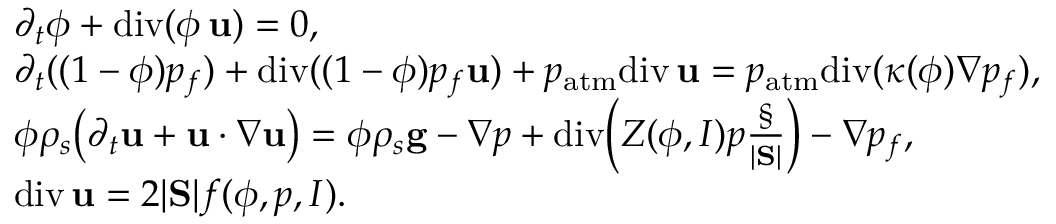<formula> <loc_0><loc_0><loc_500><loc_500>\begin{array} { r l } & { \partial _ { t } \phi + d i v ( \phi \, { u } ) = 0 , } \\ & { \partial _ { t } ( ( 1 - \phi ) p _ { f } ) + d i v ( ( 1 - \phi ) p _ { f } { u } ) + p _ { a t m } d i v \, { u } = p _ { a t m } d i v ( \kappa ( \phi ) \nabla p _ { f } ) , } \\ & { \phi \rho _ { s } \left ( \partial _ { t } { u } + { u } \cdot \nabla { u } \right ) = \phi \rho _ { s } { g } - \nabla p + d i v \left ( Z ( \phi , I ) p \frac { \S } { | S | } \right ) - \nabla p _ { f } , } \\ & { d i v \, { u } = 2 | S | f ( \phi , p , I ) . } \end{array}</formula> 